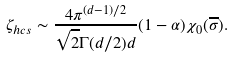Convert formula to latex. <formula><loc_0><loc_0><loc_500><loc_500>\zeta _ { h c s } \sim \frac { 4 \pi ^ { ( d - 1 ) / 2 } } { \sqrt { 2 } \Gamma ( d / 2 ) d } ( 1 - \alpha ) \chi _ { 0 } ( \overline { \sigma } ) .</formula> 